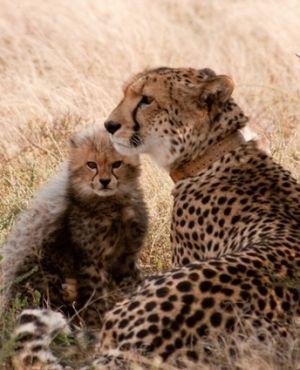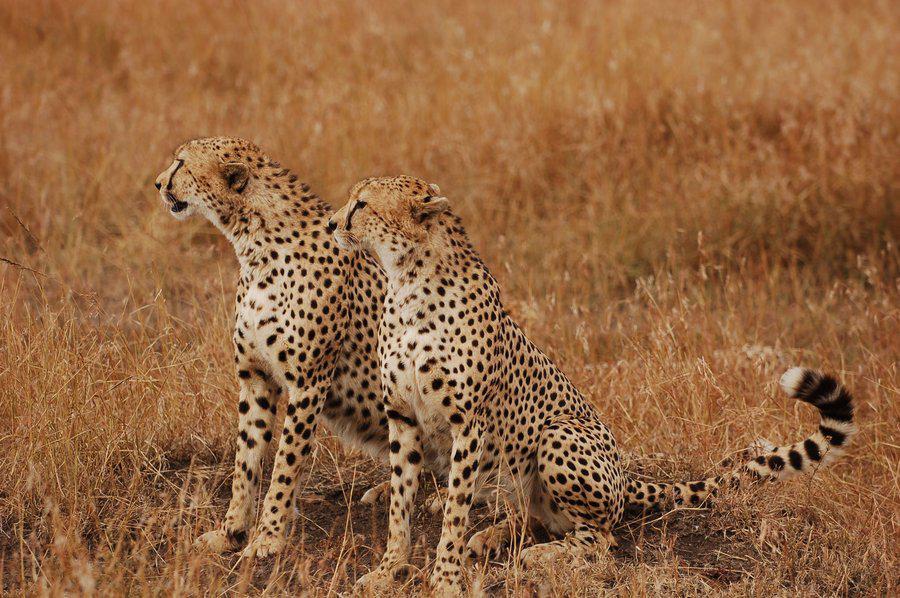The first image is the image on the left, the second image is the image on the right. Examine the images to the left and right. Is the description "There is at least two cheetahs in the left image." accurate? Answer yes or no. Yes. The first image is the image on the left, the second image is the image on the right. Given the left and right images, does the statement "One image includes three cheetahs of the same size sitting upright in a row in lookalike poses." hold true? Answer yes or no. No. 